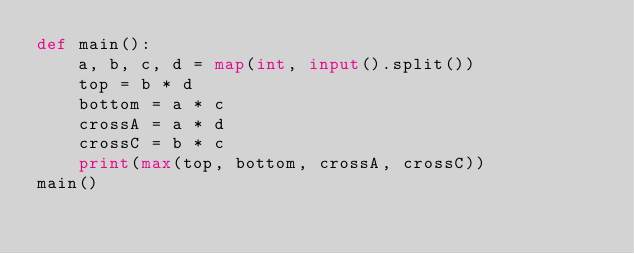<code> <loc_0><loc_0><loc_500><loc_500><_Python_>def main():
    a, b, c, d = map(int, input().split())
    top = b * d
    bottom = a * c
    crossA = a * d
    crossC = b * c
    print(max(top, bottom, crossA, crossC))
main()
</code> 